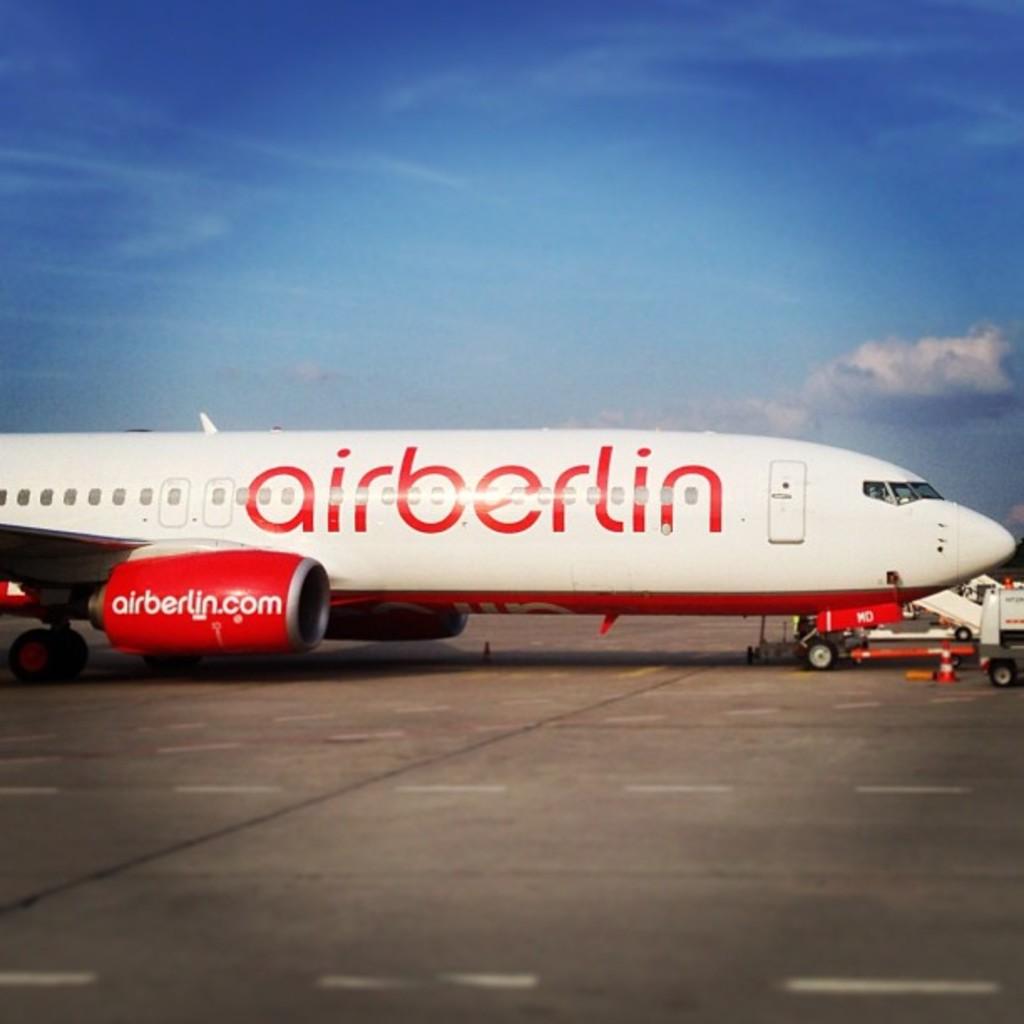What does the big print on the play say?
Keep it short and to the point. Airberlin. 